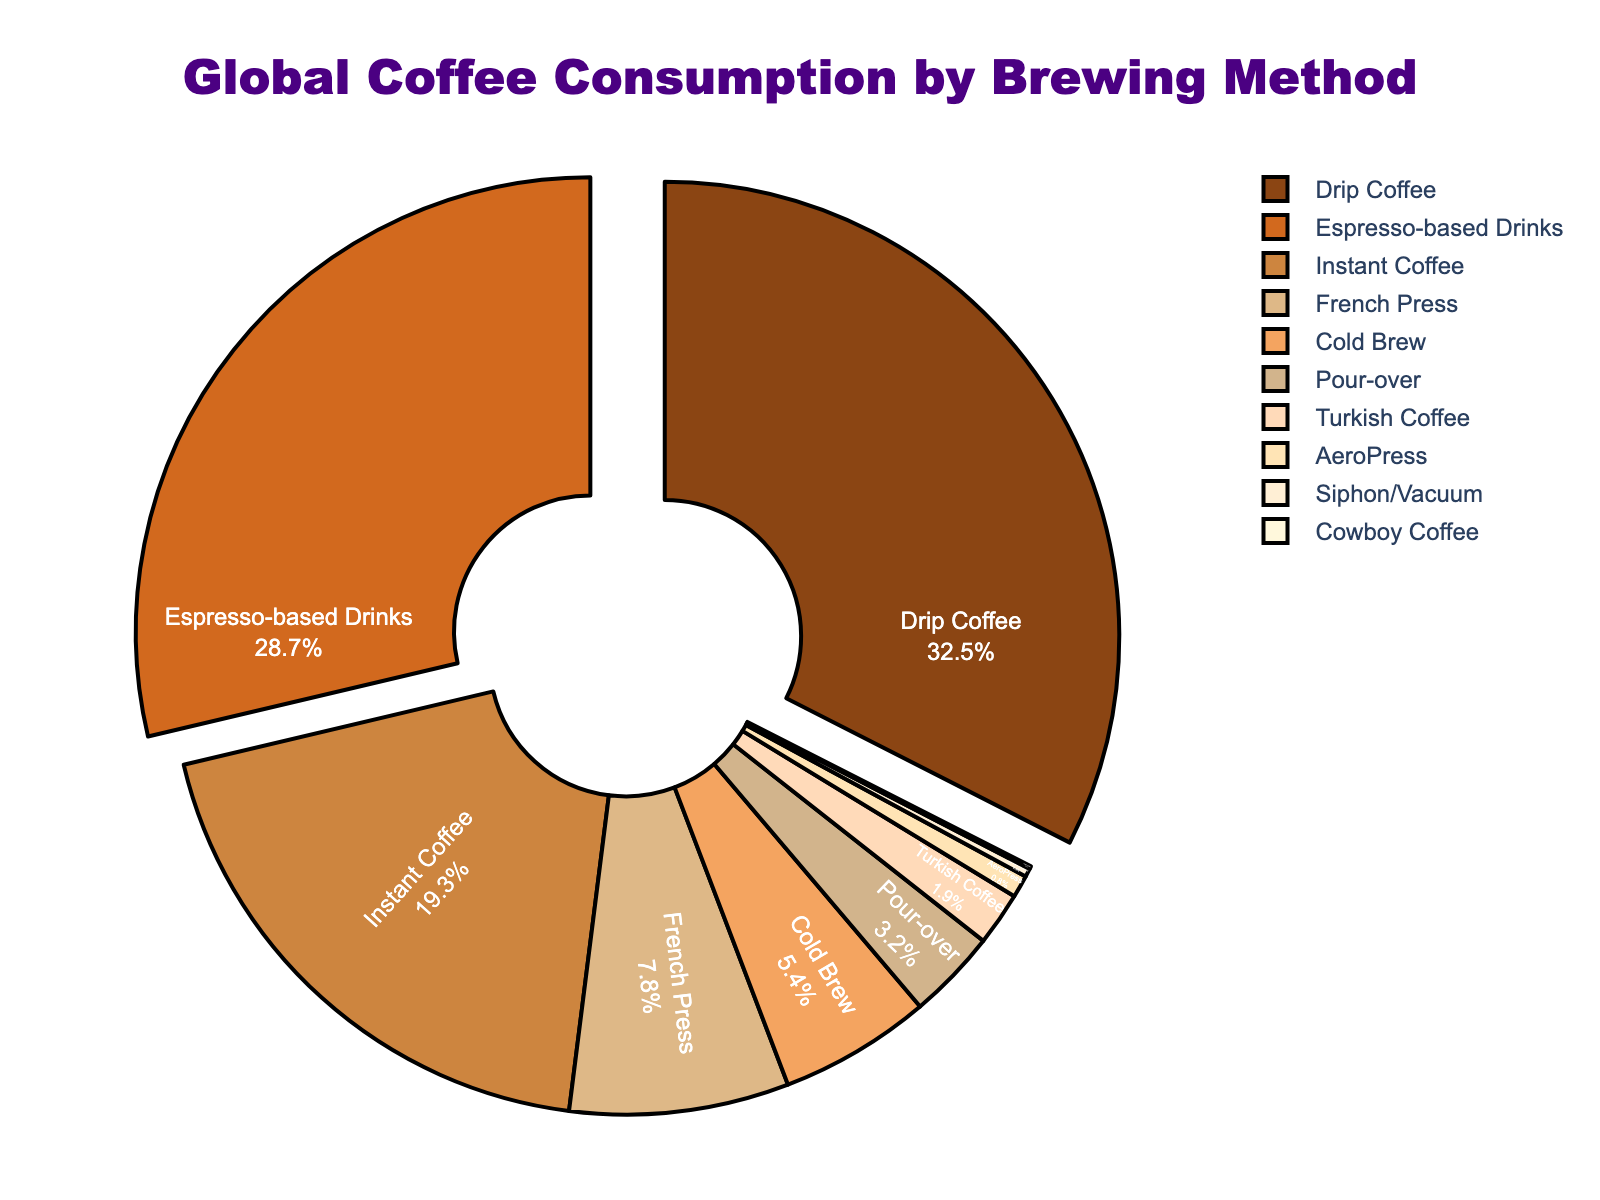What's the most popular brewing method? The largest segment in the pie chart represents the most popular brewing method based on the percentage. Drip Coffee occupies the largest portion at 32.5%.
Answer: Drip Coffee Which brewing method ranks second in coffee consumption? By examining the pie chart, the second-largest portion is assigned to Espresso-based Drinks with a percentage of 28.7%.
Answer: Espresso-based Drinks Sum up the coffee consumption percentage for French Press, Cold Brew, and Pour-over methods. Adding the percentages of French Press (7.8%), Cold Brew (5.4%), and Pour-over (3.2%): 7.8 + 5.4 + 3.2 = 16.4%.
Answer: 16.4% Which brewing method takes up the smallest portion and what's its percentage? The smallest segment is Cowboy Coffee at 0.1%, evident from its tiny slice in the pie chart.
Answer: Cowboy Coffee at 0.1% Compare the combined percentage of Drip Coffee and Espresso-based Drinks with the combined percentage of Instant Coffee and French Press. Which is greater? Sum the percentages for Drip Coffee and Espresso-based Drinks: 32.5 + 28.7 = 61.2%. Sum the percentages for Instant Coffee and French Press: 19.3 + 7.8 = 27.1%. 61.2% is greater.
Answer: 61.2% > 27.1% How much more popular is Drip Coffee compared to Turkish Coffee in percentage terms? The percentage for Drip Coffee (32.5%) minus the percentage for Turkish Coffee (1.9%) = 32.5 - 1.9 = 30.6%.
Answer: 30.6% What is the average percentage consumption for the brewing methods that are less than 5%? Calculate the average for Pour-over (3.2%), Turkish Coffee (1.9%), AeroPress (0.8%), Siphon/Vacuum (0.3%), and Cowboy Coffee (0.1%): (3.2 + 1.9 + 0.8 + 0.3 + 0.1) / 5 = 6.3 / 5 = 1.26%.
Answer: 1.26% If you combine all the brewing methods other than Drip Coffee and Espresso-based Drinks, what is their total percentage consumption? Add the percentages for Instant Coffee, French Press, Cold Brew, Pour-over, Turkish Coffee, AeroPress, Siphon/Vacuum, and Cowboy Coffee: 19.3 + 7.8 + 5.4 + 3.2 + 1.9 + 0.8 + 0.3 + 0.1 = 38.8%.
Answer: 38.8% Is the segment for Cold Brew larger or smaller than the segment for Pour-over? The Cold Brew segment is 5.4%, and the Pour-over segment is 3.2%. Therefore, Cold Brew is larger.
Answer: Larger What is the combined total percentage for the top three brewing methods? Sum the percentages for Drip Coffee (32.5%), Espresso-based Drinks (28.7%), and Instant Coffee (19.3%): 32.5 + 28.7 + 19.3 = 80.5%.
Answer: 80.5% 